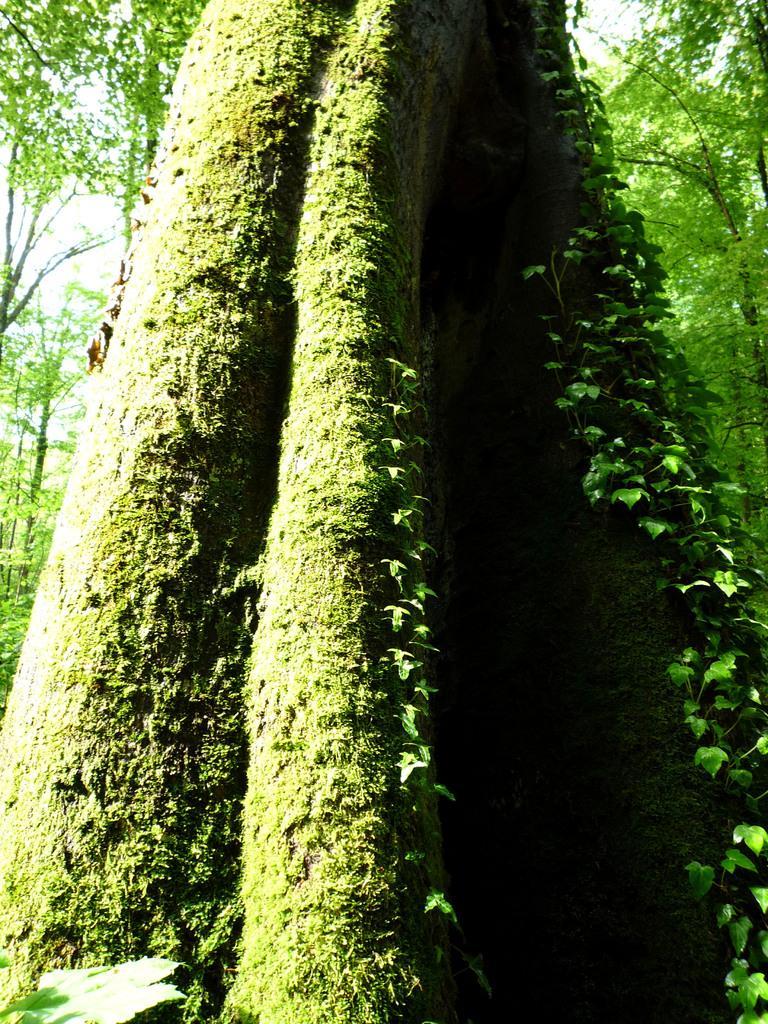How would you summarize this image in a sentence or two? In this picture we can see many trees. On the right we can see plants. On the left we can see leaves. On the top there is a sky. 